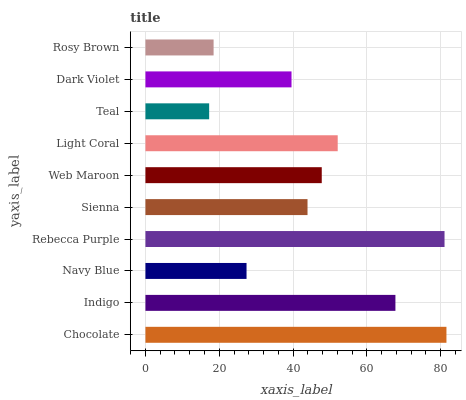Is Teal the minimum?
Answer yes or no. Yes. Is Chocolate the maximum?
Answer yes or no. Yes. Is Indigo the minimum?
Answer yes or no. No. Is Indigo the maximum?
Answer yes or no. No. Is Chocolate greater than Indigo?
Answer yes or no. Yes. Is Indigo less than Chocolate?
Answer yes or no. Yes. Is Indigo greater than Chocolate?
Answer yes or no. No. Is Chocolate less than Indigo?
Answer yes or no. No. Is Web Maroon the high median?
Answer yes or no. Yes. Is Sienna the low median?
Answer yes or no. Yes. Is Chocolate the high median?
Answer yes or no. No. Is Teal the low median?
Answer yes or no. No. 